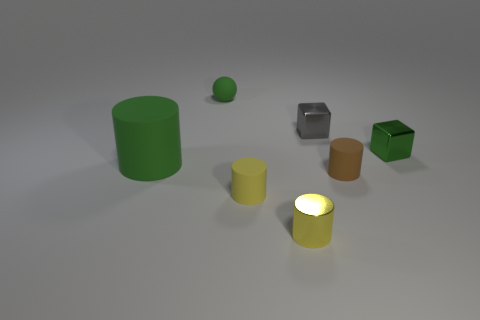What is the color of the big rubber object? The color of the large rubber object, which appears to be a cylindrical shape, is green. 